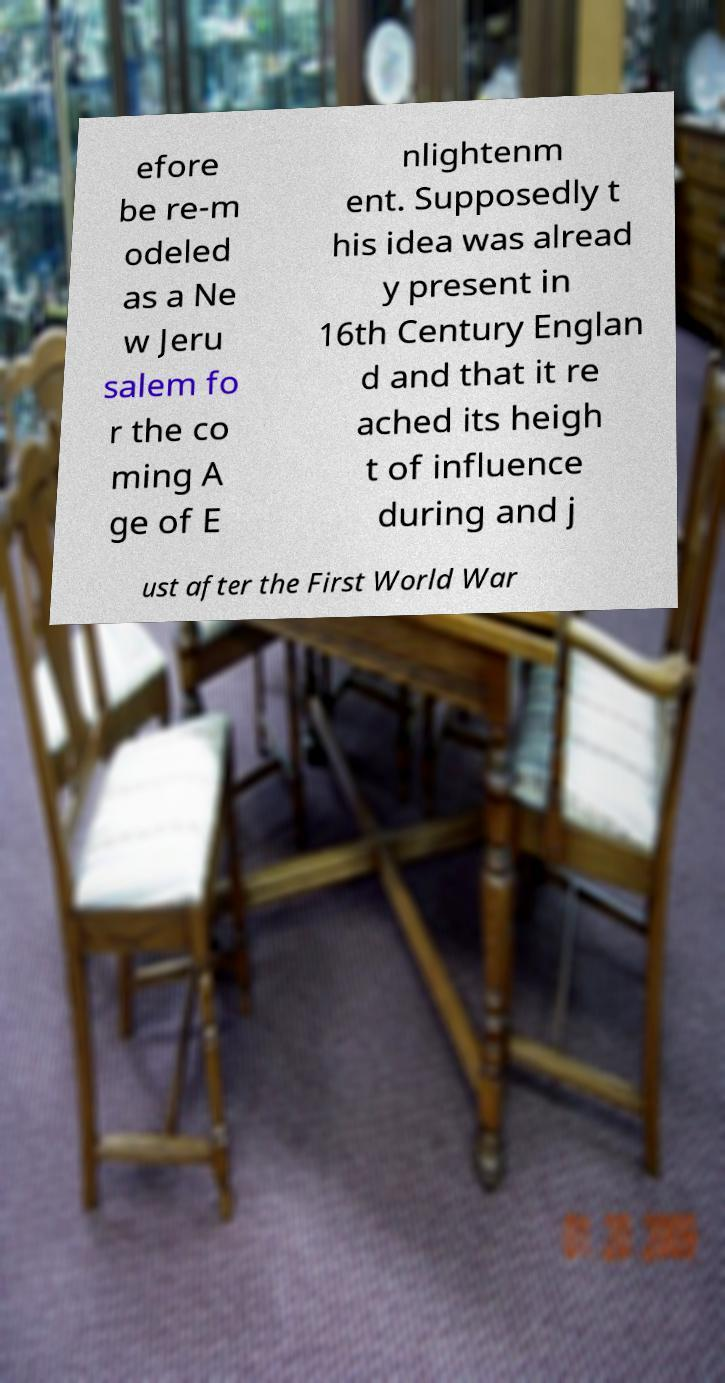I need the written content from this picture converted into text. Can you do that? efore be re-m odeled as a Ne w Jeru salem fo r the co ming A ge of E nlightenm ent. Supposedly t his idea was alread y present in 16th Century Englan d and that it re ached its heigh t of influence during and j ust after the First World War 